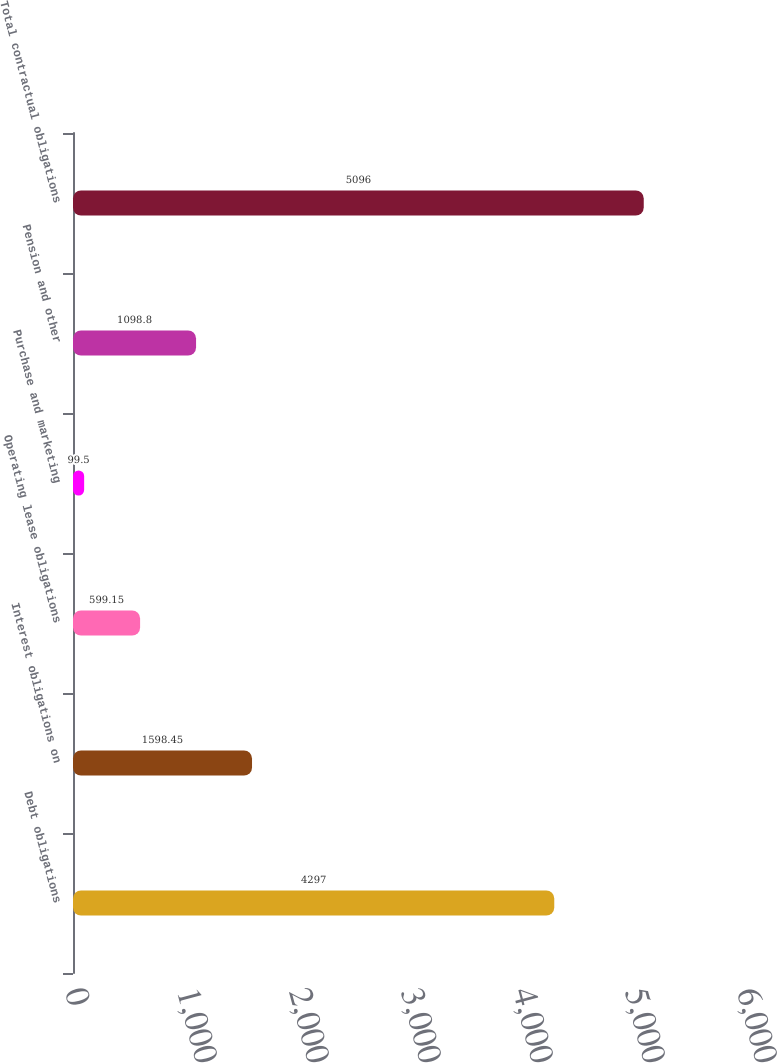Convert chart. <chart><loc_0><loc_0><loc_500><loc_500><bar_chart><fcel>Debt obligations<fcel>Interest obligations on<fcel>Operating lease obligations<fcel>Purchase and marketing<fcel>Pension and other<fcel>Total contractual obligations<nl><fcel>4297<fcel>1598.45<fcel>599.15<fcel>99.5<fcel>1098.8<fcel>5096<nl></chart> 